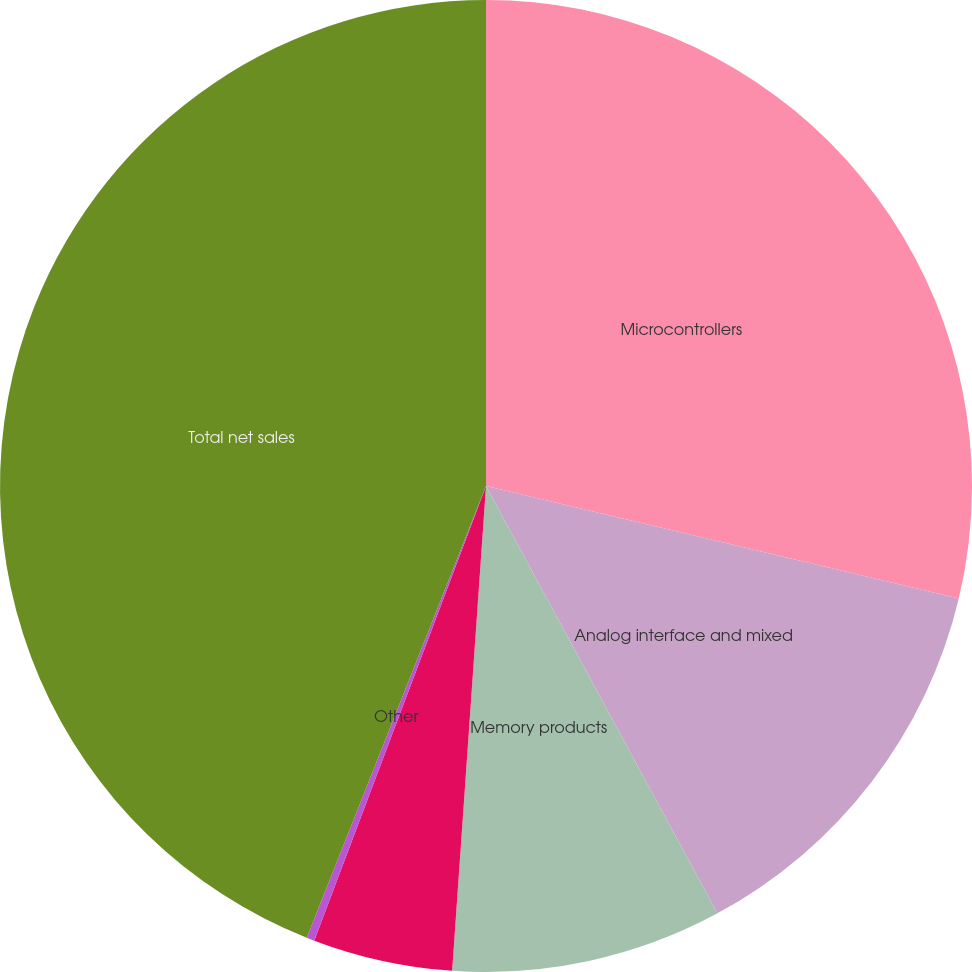Convert chart. <chart><loc_0><loc_0><loc_500><loc_500><pie_chart><fcel>Microcontrollers<fcel>Analog interface and mixed<fcel>Memory products<fcel>Technology licensing<fcel>Other<fcel>Total net sales<nl><fcel>28.72%<fcel>13.38%<fcel>9.01%<fcel>4.64%<fcel>0.26%<fcel>43.99%<nl></chart> 